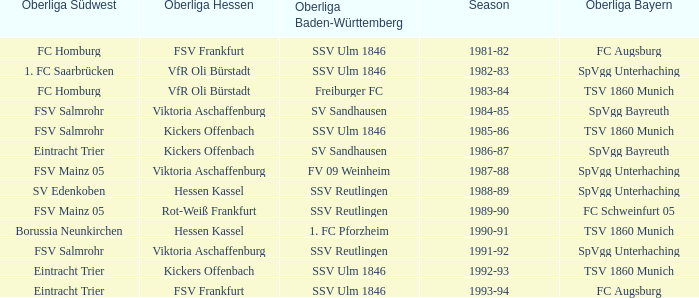Which oberliga südwes has an oberliga baden-württemberg of sv sandhausen in 1984-85? FSV Salmrohr. 